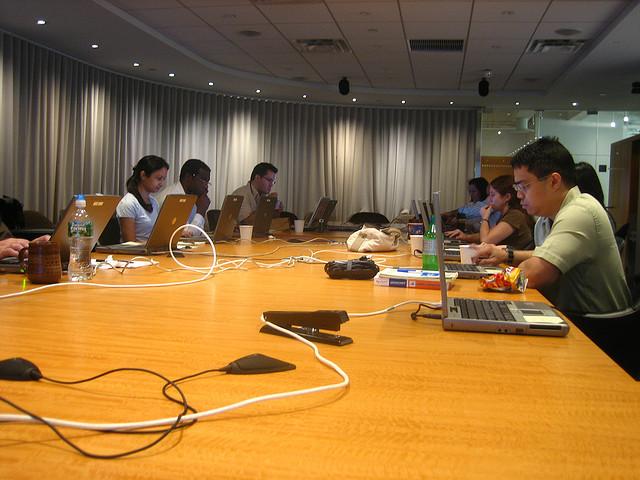What devices are in front of people?
Quick response, please. Laptops. Is this a business meeting?
Give a very brief answer. Yes. What brand are those laptops?
Keep it brief. Dell. What is the stapler touching?
Concise answer only. Cord. 